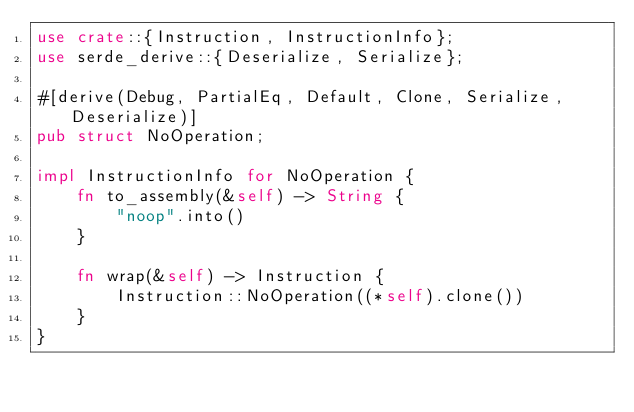Convert code to text. <code><loc_0><loc_0><loc_500><loc_500><_Rust_>use crate::{Instruction, InstructionInfo};
use serde_derive::{Deserialize, Serialize};

#[derive(Debug, PartialEq, Default, Clone, Serialize, Deserialize)]
pub struct NoOperation;

impl InstructionInfo for NoOperation {
    fn to_assembly(&self) -> String {
        "noop".into()
    }

    fn wrap(&self) -> Instruction {
        Instruction::NoOperation((*self).clone())
    }
}
</code> 